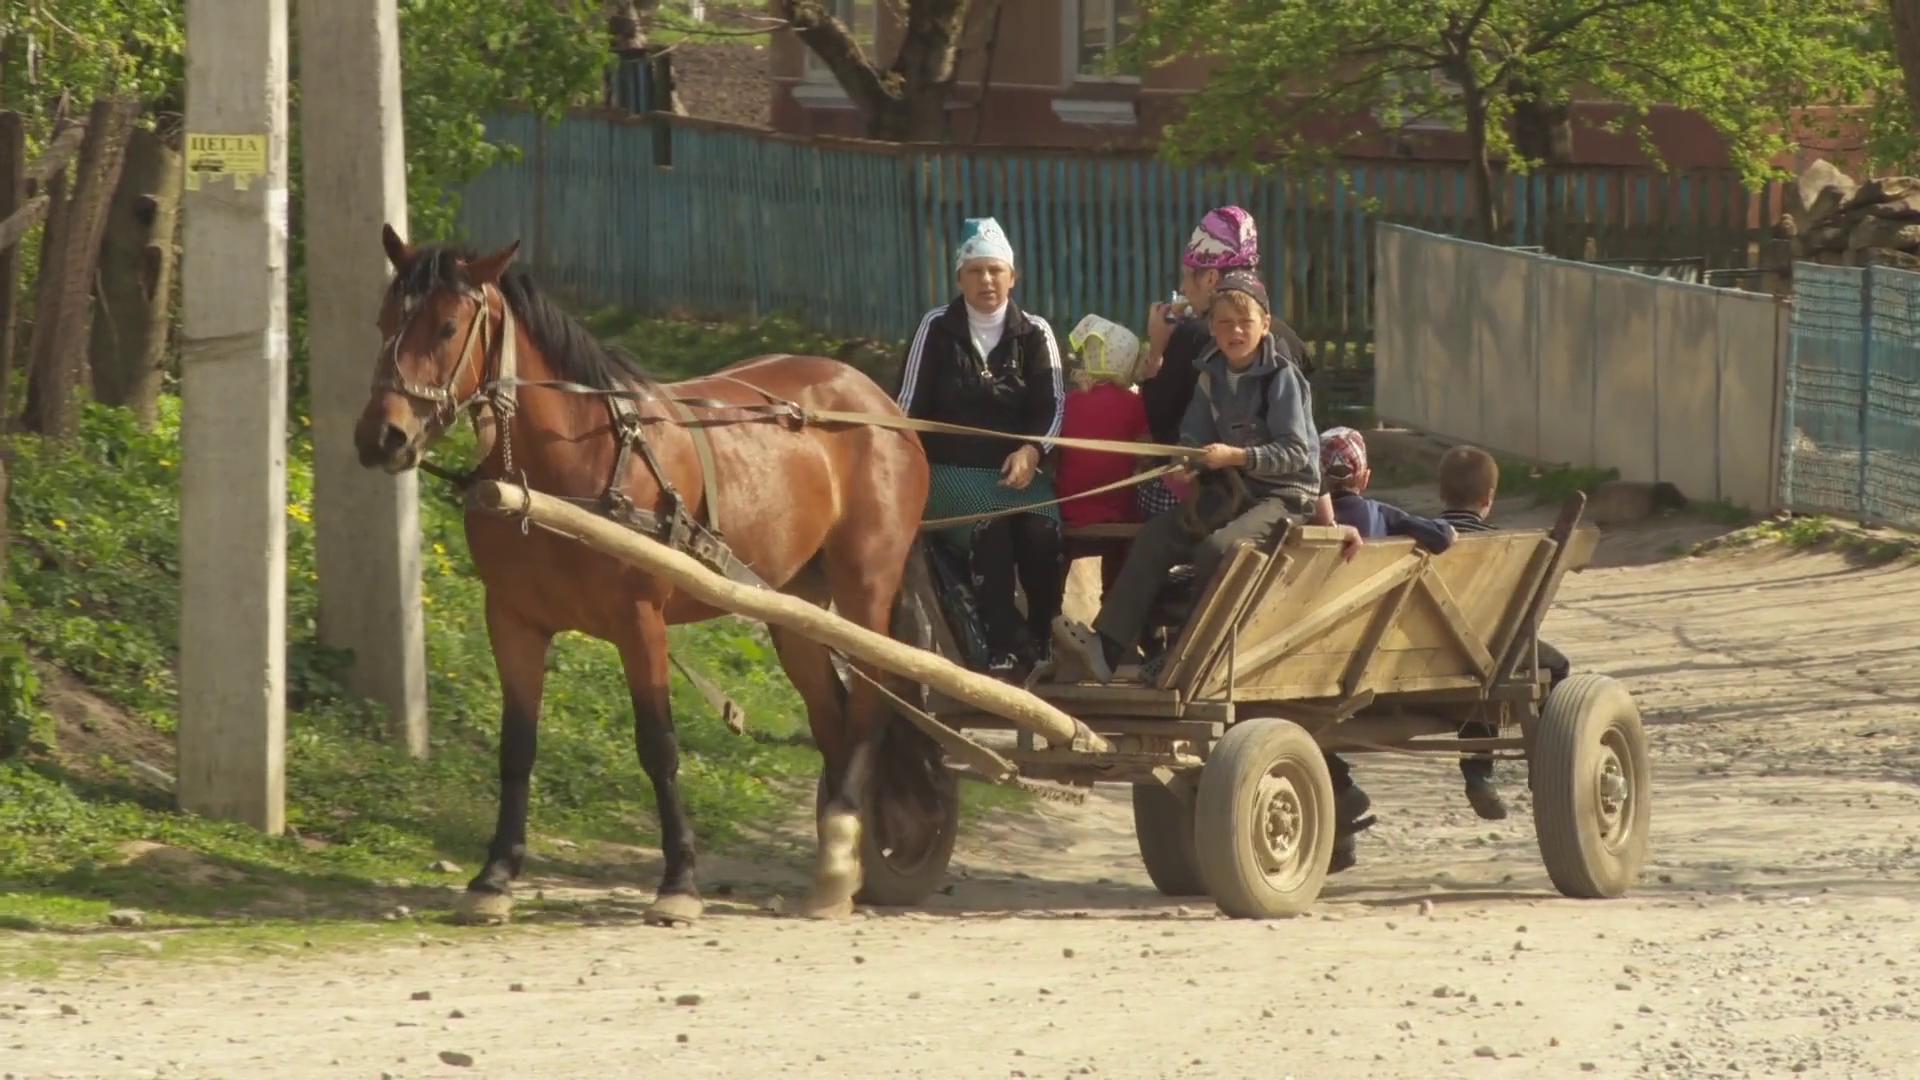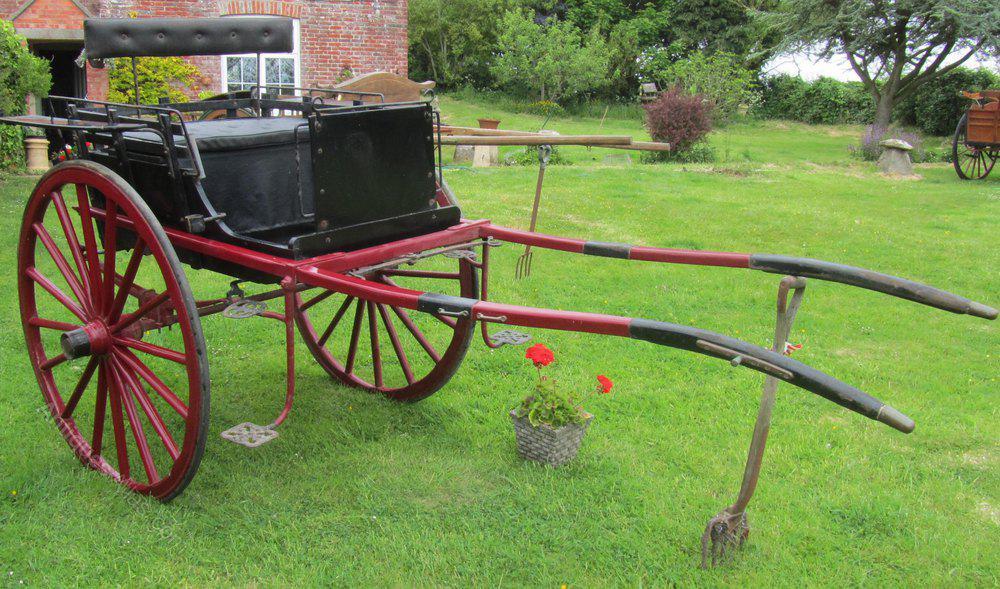The first image is the image on the left, the second image is the image on the right. Given the left and right images, does the statement "At least one image shows a two-wheeled cart with no passengers, parked on green grass." hold true? Answer yes or no. Yes. The first image is the image on the left, the second image is the image on the right. Considering the images on both sides, is "There is a two wheel cart in at least one of the images." valid? Answer yes or no. Yes. 